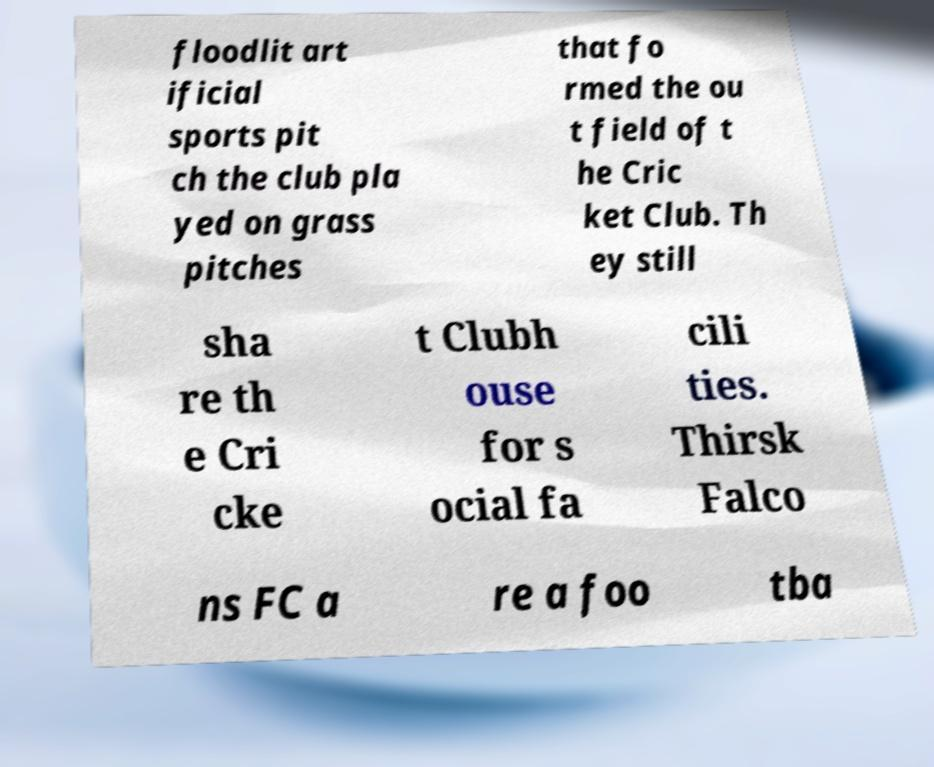Could you extract and type out the text from this image? floodlit art ificial sports pit ch the club pla yed on grass pitches that fo rmed the ou t field of t he Cric ket Club. Th ey still sha re th e Cri cke t Clubh ouse for s ocial fa cili ties. Thirsk Falco ns FC a re a foo tba 